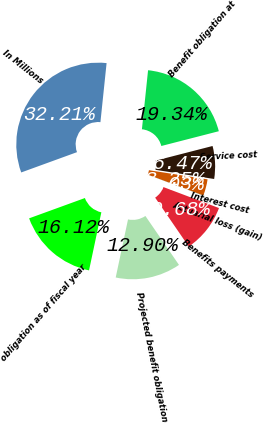<chart> <loc_0><loc_0><loc_500><loc_500><pie_chart><fcel>In Millions<fcel>Benefit obligation at<fcel>Service cost<fcel>Interest cost<fcel>Actuarial loss (gain)<fcel>Benefits payments<fcel>Projected benefit obligation<fcel>obligation as of fiscal year<nl><fcel>32.21%<fcel>19.34%<fcel>6.47%<fcel>3.25%<fcel>0.03%<fcel>9.68%<fcel>12.9%<fcel>16.12%<nl></chart> 